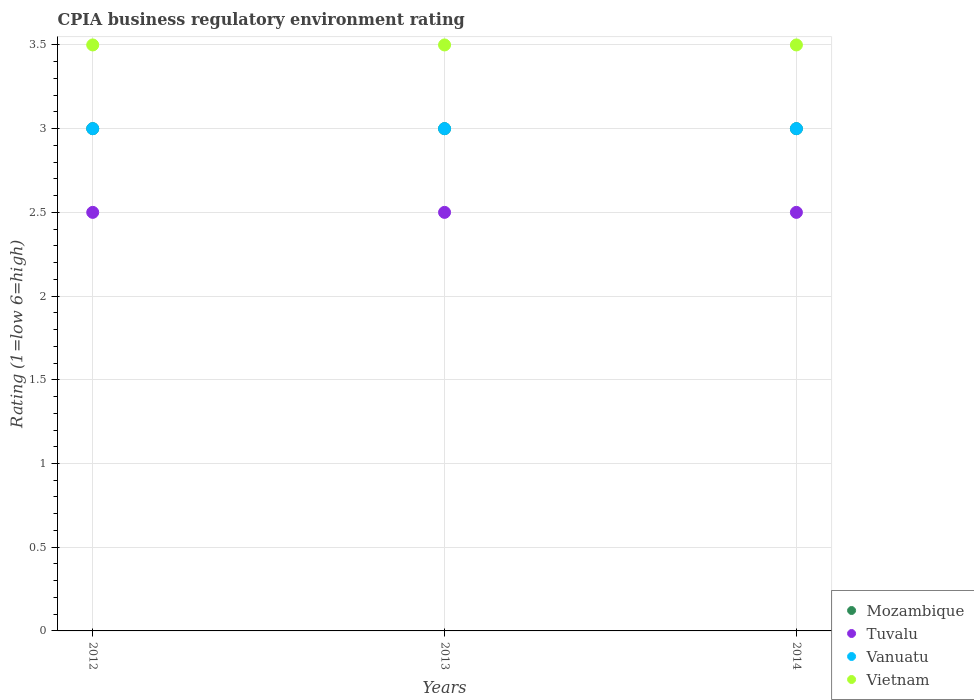How many different coloured dotlines are there?
Provide a succinct answer. 4. Is the number of dotlines equal to the number of legend labels?
Give a very brief answer. Yes. What is the CPIA rating in Mozambique in 2014?
Ensure brevity in your answer.  3. Across all years, what is the maximum CPIA rating in Mozambique?
Ensure brevity in your answer.  3. Across all years, what is the minimum CPIA rating in Vanuatu?
Provide a short and direct response. 3. In which year was the CPIA rating in Mozambique maximum?
Offer a very short reply. 2012. In which year was the CPIA rating in Mozambique minimum?
Ensure brevity in your answer.  2012. What is the total CPIA rating in Mozambique in the graph?
Offer a very short reply. 9. What is the difference between the CPIA rating in Tuvalu in 2012 and that in 2013?
Ensure brevity in your answer.  0. What is the difference between the CPIA rating in Vanuatu in 2014 and the CPIA rating in Tuvalu in 2012?
Offer a terse response. 0.5. What is the average CPIA rating in Vietnam per year?
Ensure brevity in your answer.  3.5. In the year 2012, what is the difference between the CPIA rating in Mozambique and CPIA rating in Tuvalu?
Your answer should be very brief. 0.5. Is the CPIA rating in Tuvalu in 2012 less than that in 2014?
Your answer should be compact. No. What is the difference between the highest and the second highest CPIA rating in Vanuatu?
Make the answer very short. 0. What is the difference between the highest and the lowest CPIA rating in Tuvalu?
Your answer should be very brief. 0. In how many years, is the CPIA rating in Mozambique greater than the average CPIA rating in Mozambique taken over all years?
Give a very brief answer. 0. Is it the case that in every year, the sum of the CPIA rating in Tuvalu and CPIA rating in Vietnam  is greater than the sum of CPIA rating in Mozambique and CPIA rating in Vanuatu?
Offer a very short reply. Yes. Does the CPIA rating in Tuvalu monotonically increase over the years?
Provide a short and direct response. No. Is the CPIA rating in Vietnam strictly greater than the CPIA rating in Mozambique over the years?
Your answer should be very brief. Yes. How many dotlines are there?
Offer a terse response. 4. How many years are there in the graph?
Provide a short and direct response. 3. Does the graph contain any zero values?
Make the answer very short. No. Does the graph contain grids?
Make the answer very short. Yes. Where does the legend appear in the graph?
Your answer should be very brief. Bottom right. How are the legend labels stacked?
Your answer should be compact. Vertical. What is the title of the graph?
Give a very brief answer. CPIA business regulatory environment rating. What is the label or title of the X-axis?
Provide a short and direct response. Years. What is the Rating (1=low 6=high) in Tuvalu in 2012?
Your response must be concise. 2.5. What is the Rating (1=low 6=high) in Vanuatu in 2012?
Make the answer very short. 3. What is the Rating (1=low 6=high) in Vietnam in 2012?
Your response must be concise. 3.5. What is the Rating (1=low 6=high) of Mozambique in 2013?
Provide a succinct answer. 3. What is the Rating (1=low 6=high) in Tuvalu in 2013?
Your answer should be very brief. 2.5. What is the Rating (1=low 6=high) of Vietnam in 2013?
Your answer should be very brief. 3.5. What is the Rating (1=low 6=high) of Tuvalu in 2014?
Make the answer very short. 2.5. What is the Rating (1=low 6=high) in Vanuatu in 2014?
Provide a short and direct response. 3. What is the Rating (1=low 6=high) in Vietnam in 2014?
Your answer should be very brief. 3.5. Across all years, what is the maximum Rating (1=low 6=high) of Tuvalu?
Offer a terse response. 2.5. Across all years, what is the minimum Rating (1=low 6=high) in Mozambique?
Your answer should be compact. 3. Across all years, what is the minimum Rating (1=low 6=high) in Tuvalu?
Keep it short and to the point. 2.5. Across all years, what is the minimum Rating (1=low 6=high) in Vietnam?
Provide a succinct answer. 3.5. What is the total Rating (1=low 6=high) of Mozambique in the graph?
Make the answer very short. 9. What is the total Rating (1=low 6=high) of Tuvalu in the graph?
Give a very brief answer. 7.5. What is the total Rating (1=low 6=high) of Vanuatu in the graph?
Keep it short and to the point. 9. What is the difference between the Rating (1=low 6=high) in Vanuatu in 2012 and that in 2013?
Make the answer very short. 0. What is the difference between the Rating (1=low 6=high) in Mozambique in 2013 and that in 2014?
Provide a succinct answer. 0. What is the difference between the Rating (1=low 6=high) of Mozambique in 2012 and the Rating (1=low 6=high) of Vanuatu in 2013?
Offer a very short reply. 0. What is the difference between the Rating (1=low 6=high) of Tuvalu in 2012 and the Rating (1=low 6=high) of Vietnam in 2013?
Your answer should be compact. -1. What is the difference between the Rating (1=low 6=high) of Vanuatu in 2012 and the Rating (1=low 6=high) of Vietnam in 2013?
Make the answer very short. -0.5. What is the difference between the Rating (1=low 6=high) of Mozambique in 2012 and the Rating (1=low 6=high) of Tuvalu in 2014?
Keep it short and to the point. 0.5. What is the difference between the Rating (1=low 6=high) of Mozambique in 2012 and the Rating (1=low 6=high) of Vanuatu in 2014?
Give a very brief answer. 0. What is the difference between the Rating (1=low 6=high) in Mozambique in 2012 and the Rating (1=low 6=high) in Vietnam in 2014?
Provide a succinct answer. -0.5. What is the difference between the Rating (1=low 6=high) of Mozambique in 2013 and the Rating (1=low 6=high) of Tuvalu in 2014?
Your response must be concise. 0.5. What is the difference between the Rating (1=low 6=high) of Mozambique in 2013 and the Rating (1=low 6=high) of Vanuatu in 2014?
Provide a succinct answer. 0. What is the difference between the Rating (1=low 6=high) in Mozambique in 2013 and the Rating (1=low 6=high) in Vietnam in 2014?
Your answer should be very brief. -0.5. In the year 2012, what is the difference between the Rating (1=low 6=high) in Mozambique and Rating (1=low 6=high) in Tuvalu?
Give a very brief answer. 0.5. In the year 2012, what is the difference between the Rating (1=low 6=high) in Mozambique and Rating (1=low 6=high) in Vanuatu?
Give a very brief answer. 0. In the year 2012, what is the difference between the Rating (1=low 6=high) in Tuvalu and Rating (1=low 6=high) in Vanuatu?
Make the answer very short. -0.5. In the year 2012, what is the difference between the Rating (1=low 6=high) in Tuvalu and Rating (1=low 6=high) in Vietnam?
Ensure brevity in your answer.  -1. In the year 2013, what is the difference between the Rating (1=low 6=high) of Tuvalu and Rating (1=low 6=high) of Vietnam?
Offer a very short reply. -1. In the year 2013, what is the difference between the Rating (1=low 6=high) in Vanuatu and Rating (1=low 6=high) in Vietnam?
Ensure brevity in your answer.  -0.5. In the year 2014, what is the difference between the Rating (1=low 6=high) of Mozambique and Rating (1=low 6=high) of Tuvalu?
Provide a short and direct response. 0.5. What is the ratio of the Rating (1=low 6=high) in Vanuatu in 2012 to that in 2013?
Make the answer very short. 1. What is the ratio of the Rating (1=low 6=high) of Vietnam in 2012 to that in 2013?
Provide a short and direct response. 1. What is the ratio of the Rating (1=low 6=high) of Mozambique in 2013 to that in 2014?
Provide a short and direct response. 1. What is the ratio of the Rating (1=low 6=high) in Vanuatu in 2013 to that in 2014?
Provide a short and direct response. 1. What is the difference between the highest and the second highest Rating (1=low 6=high) of Vietnam?
Ensure brevity in your answer.  0. 